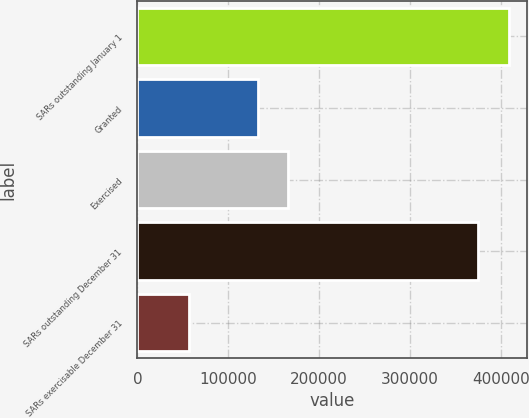Convert chart. <chart><loc_0><loc_0><loc_500><loc_500><bar_chart><fcel>SARs outstanding January 1<fcel>Granted<fcel>Exercised<fcel>SARs outstanding December 31<fcel>SARs exercisable December 31<nl><fcel>408379<fcel>132566<fcel>165841<fcel>375104<fcel>56938<nl></chart> 